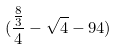<formula> <loc_0><loc_0><loc_500><loc_500>( \frac { \frac { 8 } { 3 } } { 4 } - \sqrt { 4 } - 9 4 )</formula> 